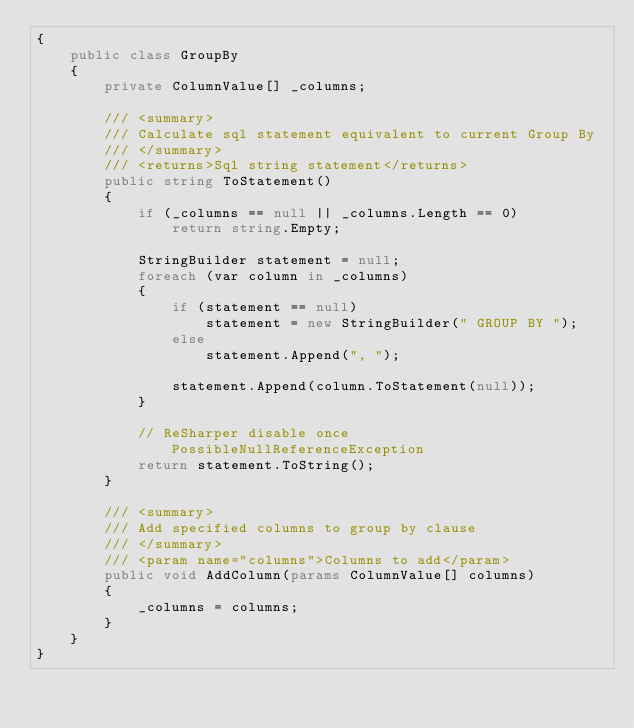<code> <loc_0><loc_0><loc_500><loc_500><_C#_>{
    public class GroupBy
    {
        private ColumnValue[] _columns;

        /// <summary>
        /// Calculate sql statement equivalent to current Group By
        /// </summary>
        /// <returns>Sql string statement</returns>
        public string ToStatement()
        {
            if (_columns == null || _columns.Length == 0)
                return string.Empty;

            StringBuilder statement = null;
            foreach (var column in _columns)
            {
                if (statement == null)
                    statement = new StringBuilder(" GROUP BY ");
                else
                    statement.Append(", ");

                statement.Append(column.ToStatement(null));
            }

            // ReSharper disable once PossibleNullReferenceException
            return statement.ToString();
        }

        /// <summary>
        /// Add specified columns to group by clause
        /// </summary>
        /// <param name="columns">Columns to add</param>
        public void AddColumn(params ColumnValue[] columns)
        {
            _columns = columns;
        }
    }
}</code> 